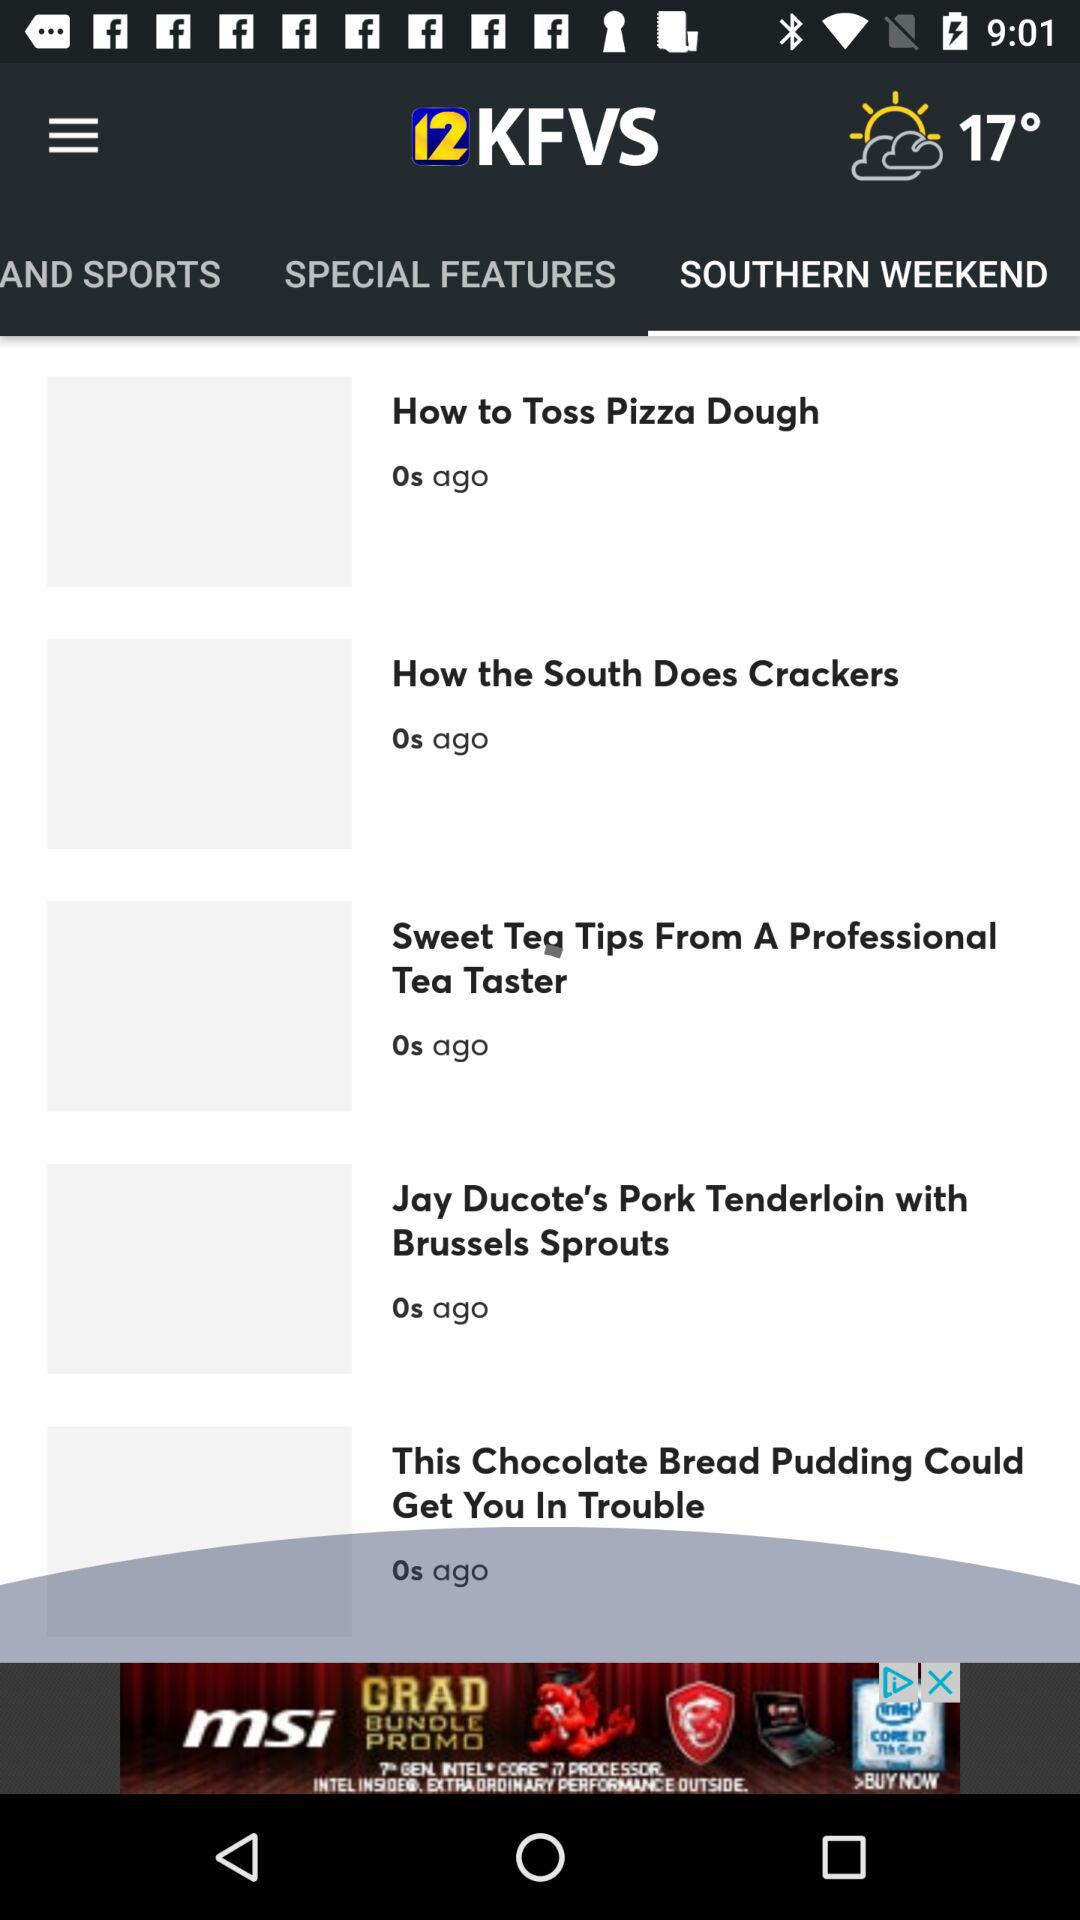What is the temperature shown on the screen? The temperature is 17°. 